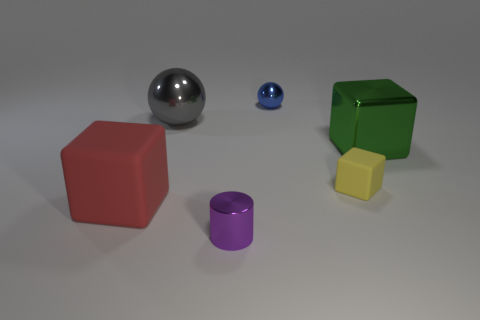How many matte objects are either big spheres or purple things?
Offer a very short reply. 0. There is a tiny object that is both in front of the blue metallic sphere and on the left side of the tiny yellow rubber block; what is its material?
Give a very brief answer. Metal. There is a big object on the right side of the small object in front of the red thing; are there any tiny yellow blocks that are on the left side of it?
Provide a succinct answer. Yes. There is a small yellow thing that is made of the same material as the red block; what is its shape?
Give a very brief answer. Cube. Are there fewer big metal spheres on the left side of the red cube than metallic objects on the left side of the tiny shiny cylinder?
Your answer should be very brief. Yes. How many tiny objects are purple things or brown objects?
Provide a succinct answer. 1. Do the matte thing right of the red thing and the matte object that is to the left of the large gray metal thing have the same shape?
Your response must be concise. Yes. How big is the shiny ball that is to the left of the small thing that is behind the matte object on the right side of the purple cylinder?
Provide a short and direct response. Large. What size is the metal thing that is to the left of the tiny purple metal thing?
Your answer should be compact. Large. What is the big block that is in front of the small yellow rubber block made of?
Your response must be concise. Rubber. 